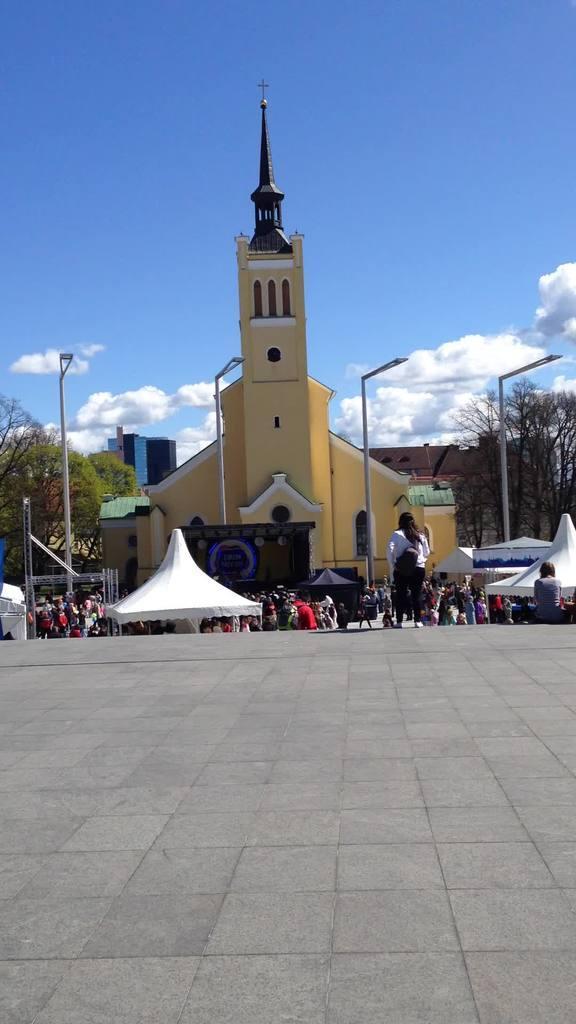Can you describe this image briefly? In this image we can see the church. We can also see the tents and also light poles and many people. In the background we can see the sky with some clouds and at the bottom there is ground. Trees are also visible in this image. 